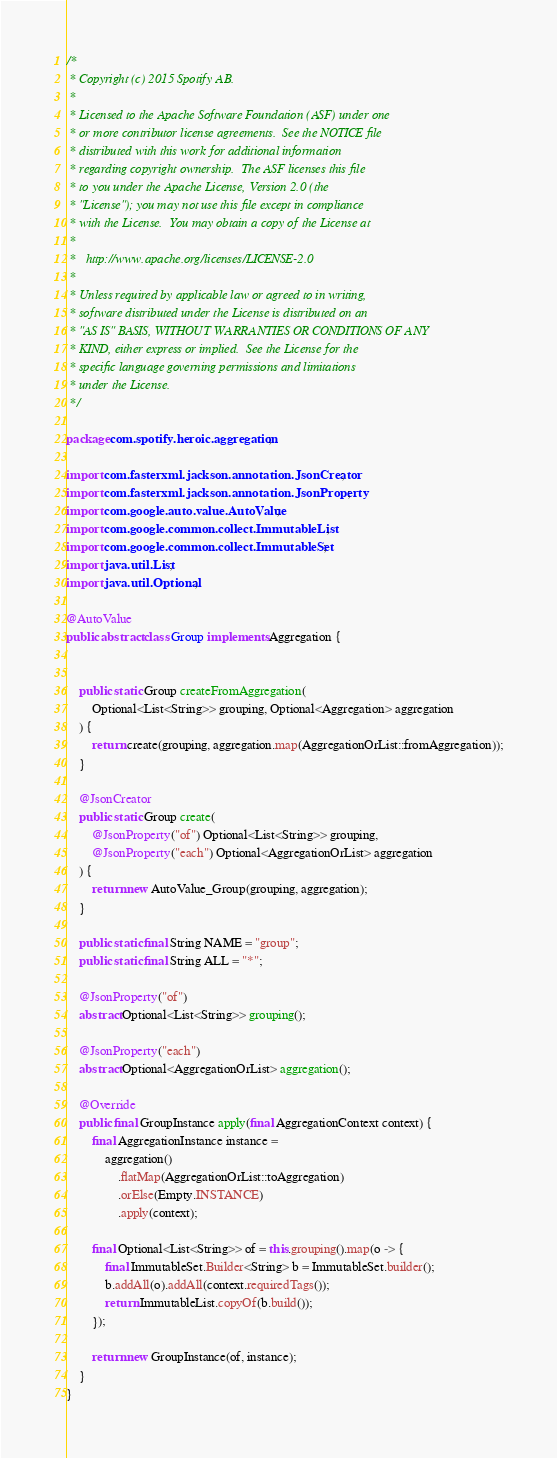<code> <loc_0><loc_0><loc_500><loc_500><_Java_>/*
 * Copyright (c) 2015 Spotify AB.
 *
 * Licensed to the Apache Software Foundation (ASF) under one
 * or more contributor license agreements.  See the NOTICE file
 * distributed with this work for additional information
 * regarding copyright ownership.  The ASF licenses this file
 * to you under the Apache License, Version 2.0 (the
 * "License"); you may not use this file except in compliance
 * with the License.  You may obtain a copy of the License at
 *
 *   http://www.apache.org/licenses/LICENSE-2.0
 *
 * Unless required by applicable law or agreed to in writing,
 * software distributed under the License is distributed on an
 * "AS IS" BASIS, WITHOUT WARRANTIES OR CONDITIONS OF ANY
 * KIND, either express or implied.  See the License for the
 * specific language governing permissions and limitations
 * under the License.
 */

package com.spotify.heroic.aggregation;

import com.fasterxml.jackson.annotation.JsonCreator;
import com.fasterxml.jackson.annotation.JsonProperty;
import com.google.auto.value.AutoValue;
import com.google.common.collect.ImmutableList;
import com.google.common.collect.ImmutableSet;
import java.util.List;
import java.util.Optional;

@AutoValue
public abstract class Group implements Aggregation {


    public static Group createFromAggregation(
        Optional<List<String>> grouping, Optional<Aggregation> aggregation
    ) {
        return create(grouping, aggregation.map(AggregationOrList::fromAggregation));
    }

    @JsonCreator
    public static Group create(
        @JsonProperty("of") Optional<List<String>> grouping,
        @JsonProperty("each") Optional<AggregationOrList> aggregation
    ) {
        return new AutoValue_Group(grouping, aggregation);
    }

    public static final String NAME = "group";
    public static final String ALL = "*";

    @JsonProperty("of")
    abstract Optional<List<String>> grouping();

    @JsonProperty("each")
    abstract Optional<AggregationOrList> aggregation();

    @Override
    public final GroupInstance apply(final AggregationContext context) {
        final AggregationInstance instance =
            aggregation()
                .flatMap(AggregationOrList::toAggregation)
                .orElse(Empty.INSTANCE)
                .apply(context);

        final Optional<List<String>> of = this.grouping().map(o -> {
            final ImmutableSet.Builder<String> b = ImmutableSet.builder();
            b.addAll(o).addAll(context.requiredTags());
            return ImmutableList.copyOf(b.build());
        });

        return new GroupInstance(of, instance);
    }
}
</code> 